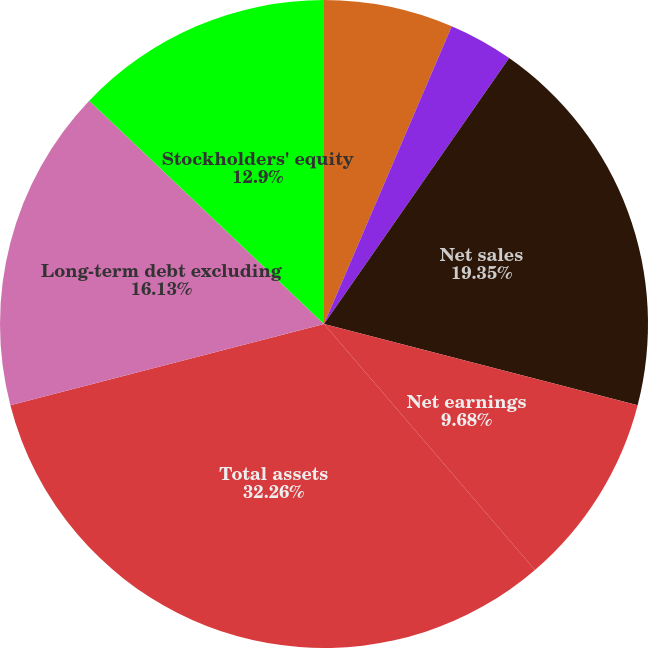<chart> <loc_0><loc_0><loc_500><loc_500><pie_chart><fcel>Earnings per share - basic<fcel>Earnings per share - diluted<fcel>Net sales<fcel>Net earnings<fcel>Total assets<fcel>Long-term debt excluding<fcel>Stockholders' equity<fcel>Dividends per share<nl><fcel>6.45%<fcel>3.23%<fcel>19.35%<fcel>9.68%<fcel>32.25%<fcel>16.13%<fcel>12.9%<fcel>0.0%<nl></chart> 